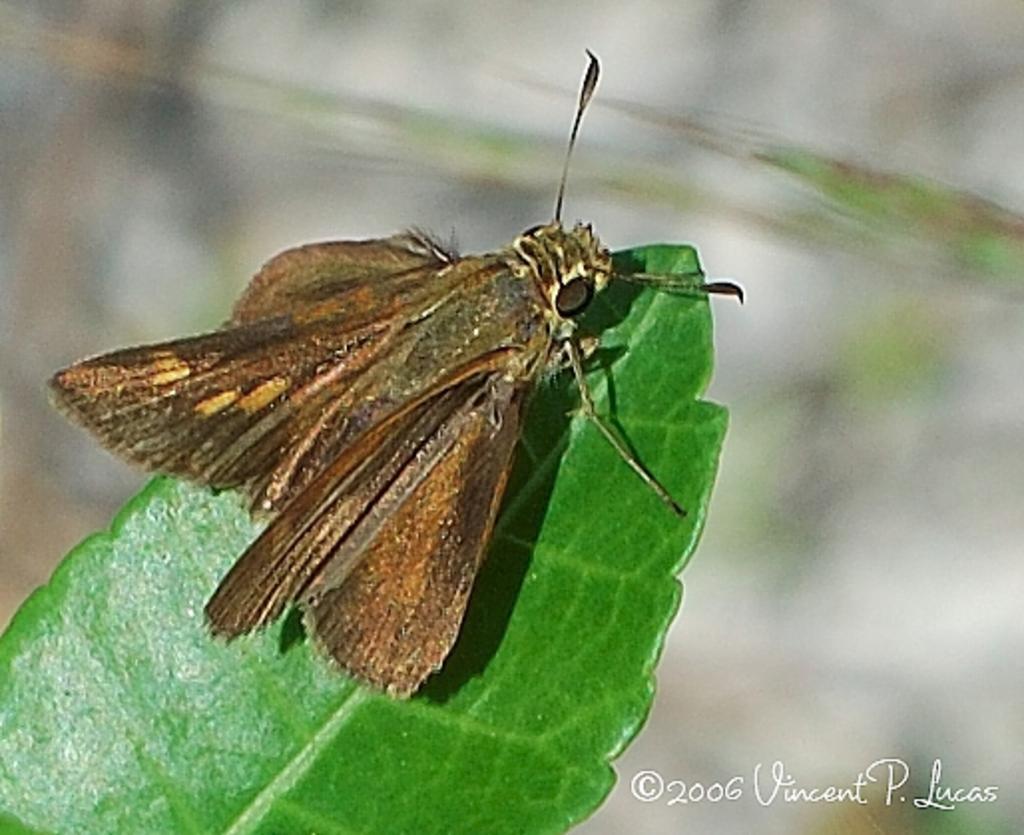Could you give a brief overview of what you see in this image? In this picture there is an insect on the green leaf. At the back image is blurry. At the bottom right there is text. 